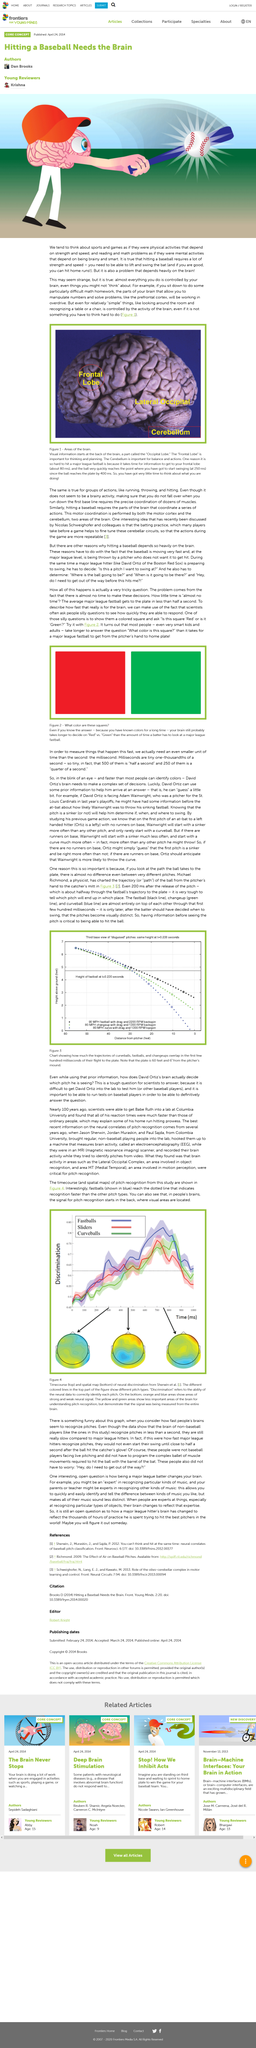Point out several critical features in this image. In our daily lives, we often think of mental activities as if they were physical tasks that require strength and speed, likening them to sports and games. The activity of the brain controls a variety of relatively simple things, such as recognizing objects in one's environment, like a table or chair. Reading and math problems are often thought of as mental activities that require intelligence and smartness, as if they were dependent on being brainy. 